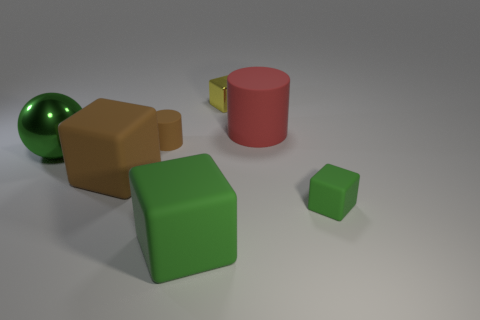What number of big cyan metal cylinders are there?
Your response must be concise. 0. There is a small block behind the big cylinder; what color is it?
Your response must be concise. Yellow. The yellow metallic thing is what size?
Your response must be concise. Small. There is a large matte cylinder; is its color the same as the tiny cube behind the large metal object?
Give a very brief answer. No. What color is the big matte block that is behind the large rubber block that is in front of the brown matte cube?
Give a very brief answer. Brown. Is the shape of the big green thing that is in front of the brown rubber cube the same as  the tiny green thing?
Ensure brevity in your answer.  Yes. How many objects are on the right side of the yellow block and in front of the brown cube?
Provide a succinct answer. 1. There is a small matte object that is on the left side of the object that is in front of the tiny block that is in front of the big cylinder; what color is it?
Your response must be concise. Brown. How many blocks are right of the cube behind the big rubber cylinder?
Ensure brevity in your answer.  1. How many other objects are the same shape as the tiny brown rubber object?
Offer a very short reply. 1. 